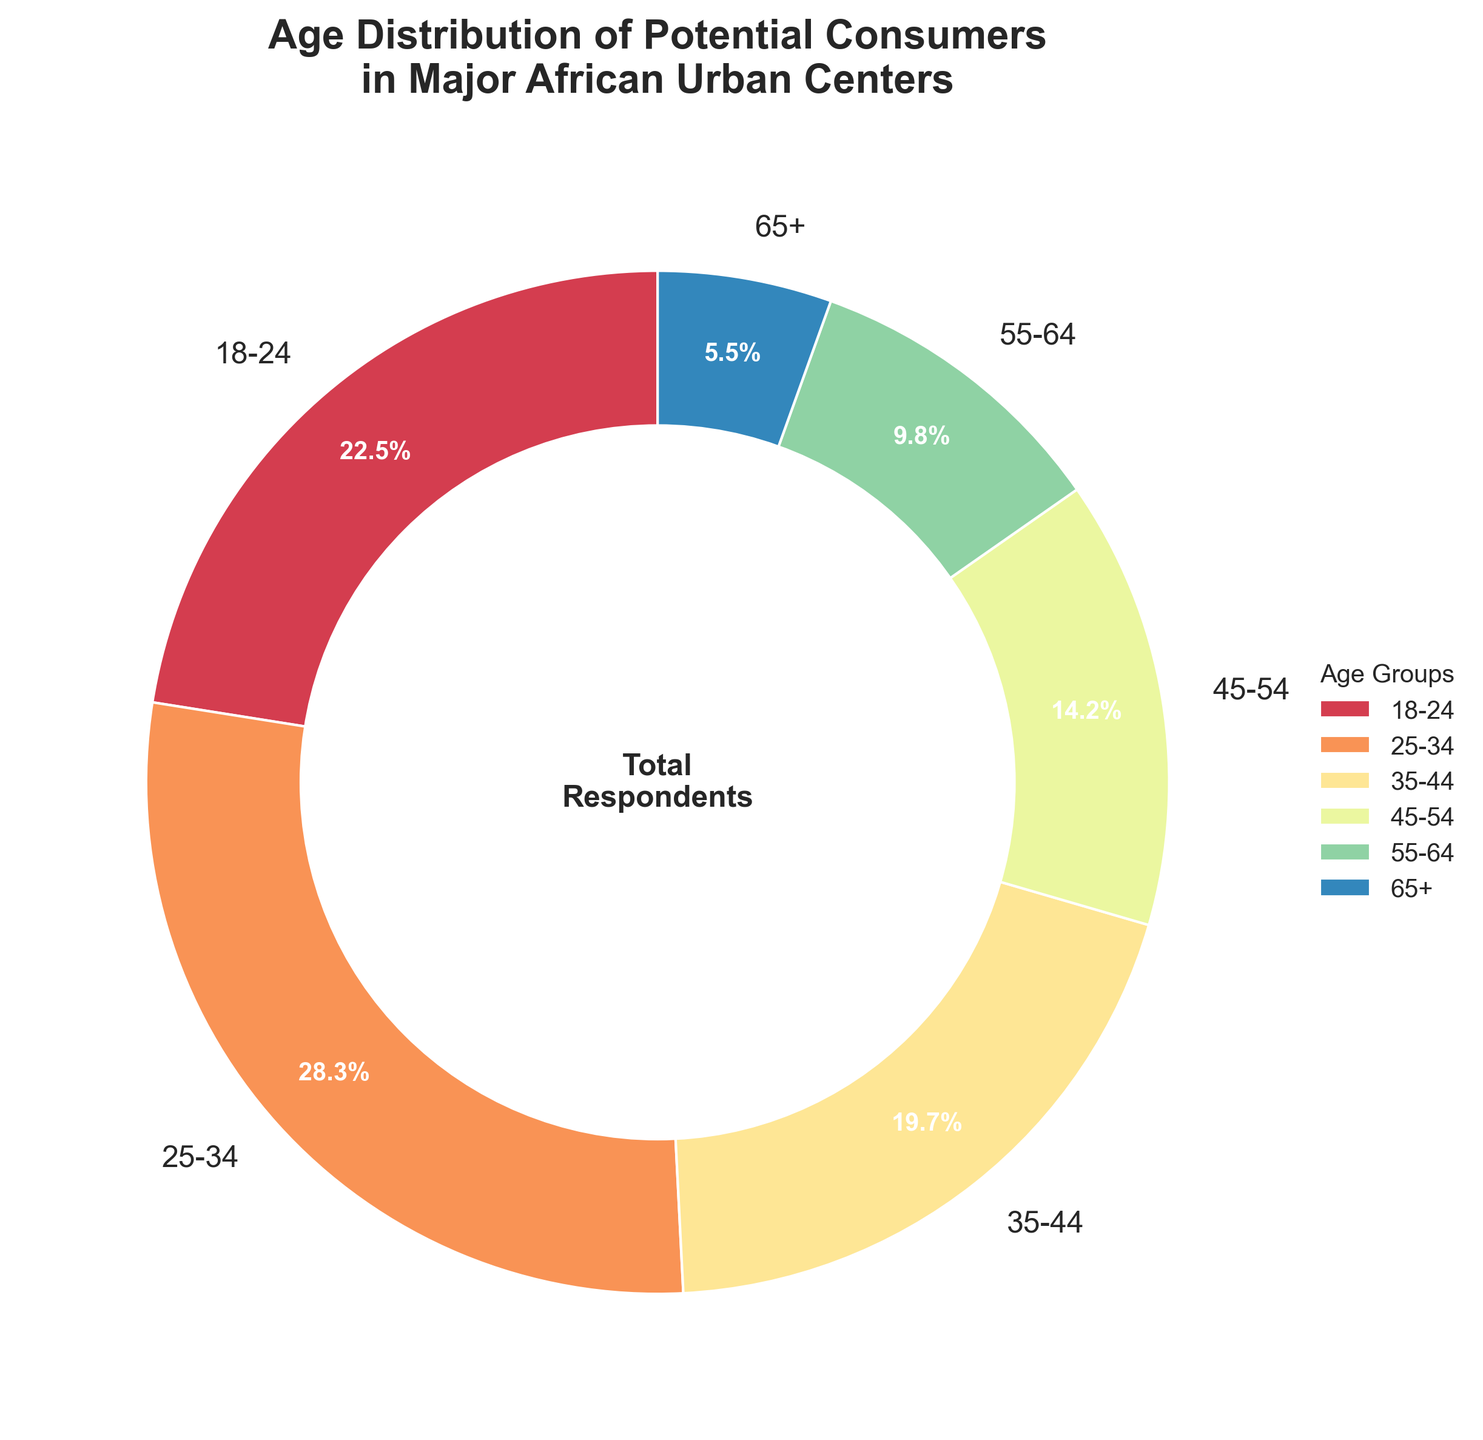Which age group has the highest percentage of potential consumers? The group with the highest percentage can be identified by comparing the percentages of all age groups. The 25-34 age group has the highest percentage at 28.3%.
Answer: 25-34 What is the combined percentage of consumers aged 18-24 and 25-34? To find the combined percentage, add the percentages of the 18-24 and 25-34 age groups: 22.5% + 28.3% = 50.8%.
Answer: 50.8% Which age group has the smallest share of potential consumers? The group with the smallest percentage can be identified by comparing the percentages of all age groups. The 65+ age group has the smallest percentage at 5.5%.
Answer: 65+ How much larger is the percentage of the 25-34 age group compared to the 45-54 age group? Subtract the percentage of the 45-54 age group from the percentage of the 25-34 age group: 28.3% - 14.2% = 14.1%.
Answer: 14.1% What percentage of the potential consumers are aged 35-64? Add the percentages of the 35-44, 45-54, and 55-64 age groups: 19.7% + 14.2% + 9.8% = 43.7%.
Answer: 43.7% Is the percentage of the 65+ age group greater than 10%? Compare the percentage of the 65+ age group with 10%. The 65+ age group has a percentage of 5.5%, which is less than 10%.
Answer: No What is the visual color representation of the 18-24 age group in the pie chart? The visual color of each segment can be identified by referring to the distinct colors used in the pie chart for each age group. The color for the 18-24 age group is distinct based on the colormap used.
Answer: Orange (as an example, this answer may vary) How does the percentage of the 25-34 age group compare to twice the percentage of the 55-64 age group? First, calculate twice the percentage of the 55-64 age group: 9.8% * 2 = 19.6%. Then compare it to the percentage of the 25-34 age group, which is 28.3%.
Answer: 25-34 is larger What is the total percentage of consumers under the age of 35? Add the percentages of the 18-24 and 25-34 age groups: 22.5% + 28.3% = 50.8%.
Answer: 50.8% If the target market is consumers aged 25-54, what percentage of the total target market does the 35-44 age group represent? First, find the total percentage for the 25-54 age groups: 28.3% + 19.7% + 14.2% = 62.2%. Then calculate the percentage contribution of the 35-44 age group: (19.7 / 62.2) * 100 ≈ 31.7%.
Answer: 31.7% 